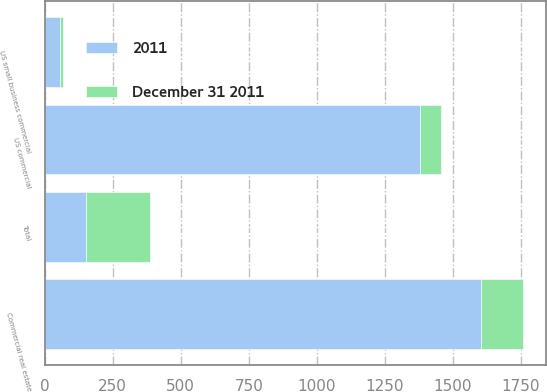Convert chart to OTSL. <chart><loc_0><loc_0><loc_500><loc_500><stacked_bar_chart><ecel><fcel>US commercial<fcel>Commercial real estate<fcel>US small business commercial<fcel>Total<nl><fcel>2011<fcel>1381<fcel>1604<fcel>58<fcel>152<nl><fcel>December 31 2011<fcel>74<fcel>152<fcel>10<fcel>236<nl></chart> 